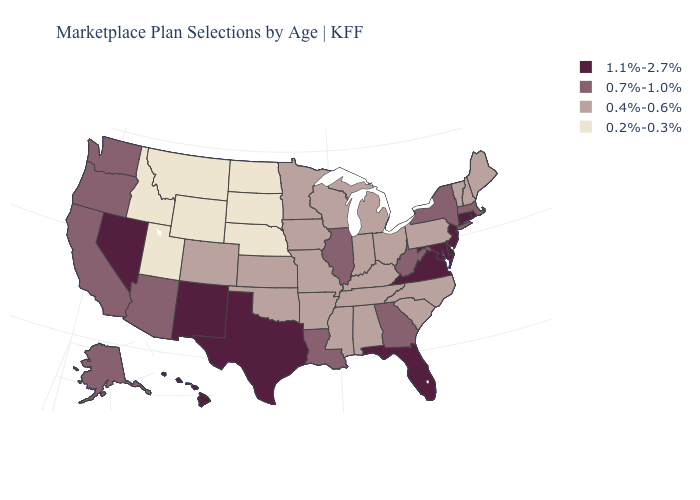Name the states that have a value in the range 0.2%-0.3%?
Give a very brief answer. Idaho, Montana, Nebraska, North Dakota, South Dakota, Utah, Wyoming. Name the states that have a value in the range 0.4%-0.6%?
Answer briefly. Alabama, Arkansas, Colorado, Indiana, Iowa, Kansas, Kentucky, Maine, Michigan, Minnesota, Mississippi, Missouri, New Hampshire, North Carolina, Ohio, Oklahoma, Pennsylvania, South Carolina, Tennessee, Vermont, Wisconsin. Does Alabama have the highest value in the USA?
Be succinct. No. Does the first symbol in the legend represent the smallest category?
Give a very brief answer. No. What is the lowest value in the USA?
Be succinct. 0.2%-0.3%. Does Iowa have the same value as Michigan?
Write a very short answer. Yes. Which states hav the highest value in the MidWest?
Short answer required. Illinois. Which states have the lowest value in the USA?
Keep it brief. Idaho, Montana, Nebraska, North Dakota, South Dakota, Utah, Wyoming. Does the first symbol in the legend represent the smallest category?
Give a very brief answer. No. Name the states that have a value in the range 0.4%-0.6%?
Give a very brief answer. Alabama, Arkansas, Colorado, Indiana, Iowa, Kansas, Kentucky, Maine, Michigan, Minnesota, Mississippi, Missouri, New Hampshire, North Carolina, Ohio, Oklahoma, Pennsylvania, South Carolina, Tennessee, Vermont, Wisconsin. Name the states that have a value in the range 0.7%-1.0%?
Give a very brief answer. Alaska, Arizona, California, Georgia, Illinois, Louisiana, Massachusetts, New York, Oregon, Washington, West Virginia. Does Wisconsin have a higher value than Michigan?
Short answer required. No. What is the value of Ohio?
Short answer required. 0.4%-0.6%. What is the value of Indiana?
Be succinct. 0.4%-0.6%. What is the value of North Dakota?
Write a very short answer. 0.2%-0.3%. 